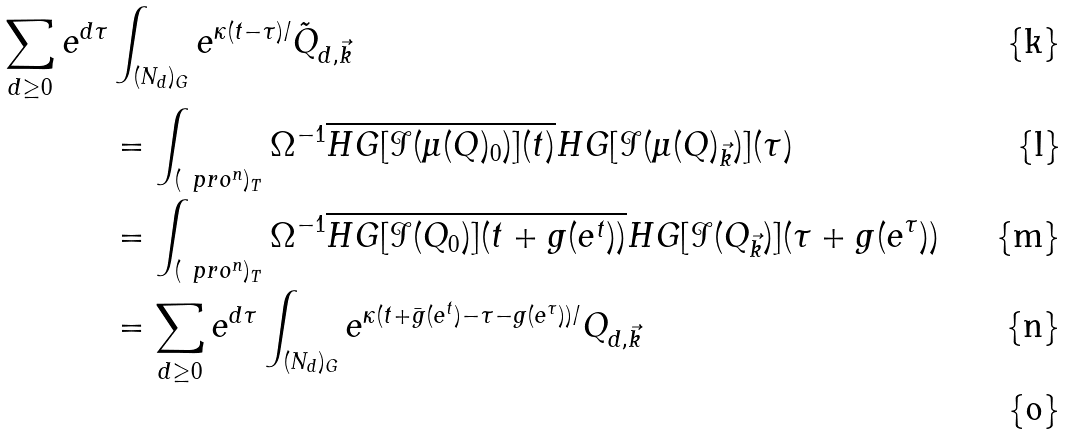Convert formula to latex. <formula><loc_0><loc_0><loc_500><loc_500>\sum _ { d \geq 0 } e ^ { d \tau } & \int _ { ( N _ { d } ) _ { G } } e ^ { \kappa ( t - \tau ) / } \tilde { Q } _ { d , \vec { k } } \\ & = \int _ { ( \ p r o ^ { n } ) _ { T } } \Omega ^ { - 1 } \overline { H G [ \mathcal { I } ( \mu ( Q ) _ { 0 } ) ] ( t ) } H G [ \mathcal { I } ( \mu ( Q ) _ { \vec { k } } ) ] ( \tau ) \\ & = \int _ { ( \ p r o ^ { n } ) _ { T } } \Omega ^ { - 1 } \overline { H G [ \mathcal { I } ( Q _ { 0 } ) ] ( t + g ( e ^ { t } ) ) } H G [ \mathcal { I } ( Q _ { \vec { k } } ) ] ( \tau + g ( e ^ { \tau } ) ) \\ & = \sum _ { d \geq 0 } e ^ { d \tau } \int _ { ( N _ { d } ) _ { G } } e ^ { \kappa ( t + \bar { g } ( e ^ { t } ) - \tau - g ( e ^ { \tau } ) ) / } Q _ { d , \vec { k } } \\</formula> 